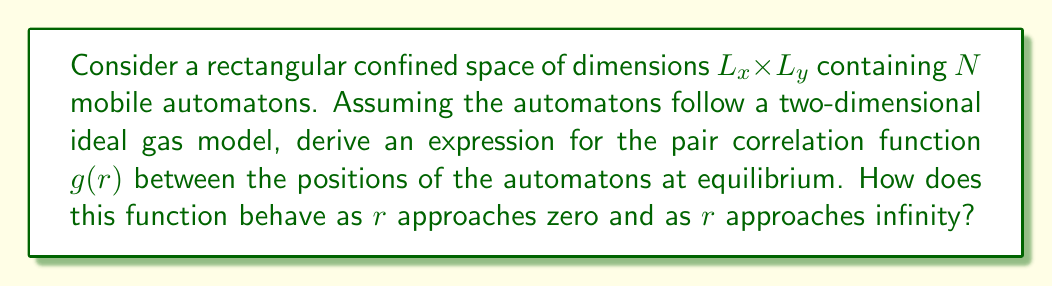Solve this math problem. Let's approach this step-by-step:

1) In statistical mechanics, the pair correlation function $g(r)$ describes how the density of particles varies as a function of distance from a reference particle.

2) For an ideal gas model in two dimensions, we can use the canonical ensemble to describe the system. The probability of finding two particles at a distance $r$ is proportional to the Boltzmann factor:

   $$P(r) \propto e^{-\beta U(r)}$$

   where $\beta = \frac{1}{k_BT}$ and $U(r)$ is the interaction potential.

3) For an ideal gas, there are no interactions between particles, so $U(r) = 0$ for all $r$. This means:

   $$P(r) \propto 1$$

4) The pair correlation function $g(r)$ is related to this probability, normalized by the average density. In a confined space of area $A = L_x L_y$, the average density is $\rho = N/A$. Therefore:

   $$g(r) = \frac{P(r)}{\rho} = \frac{A}{N}$$

5) This constant value holds true for all $r$ greater than the size of the automatons. At very small $r$, less than the size of an automaton, $g(r)$ would drop to zero due to the physical impossibility of overlap.

6) As $r$ approaches infinity, $g(r)$ maintains this constant value, indicating no long-range order in the system.

7) It's worth noting that in a confined space, there will be some deviations from this ideal behavior near the boundaries, but these effects become negligible as $N$ becomes large.
Answer: $g(r) = \frac{L_x L_y}{N}$ for $r > r_0$, where $r_0$ is the automaton size; $g(r) = 0$ for $r \leq r_0$; $\lim_{r \to \infty} g(r) = \frac{L_x L_y}{N}$ 